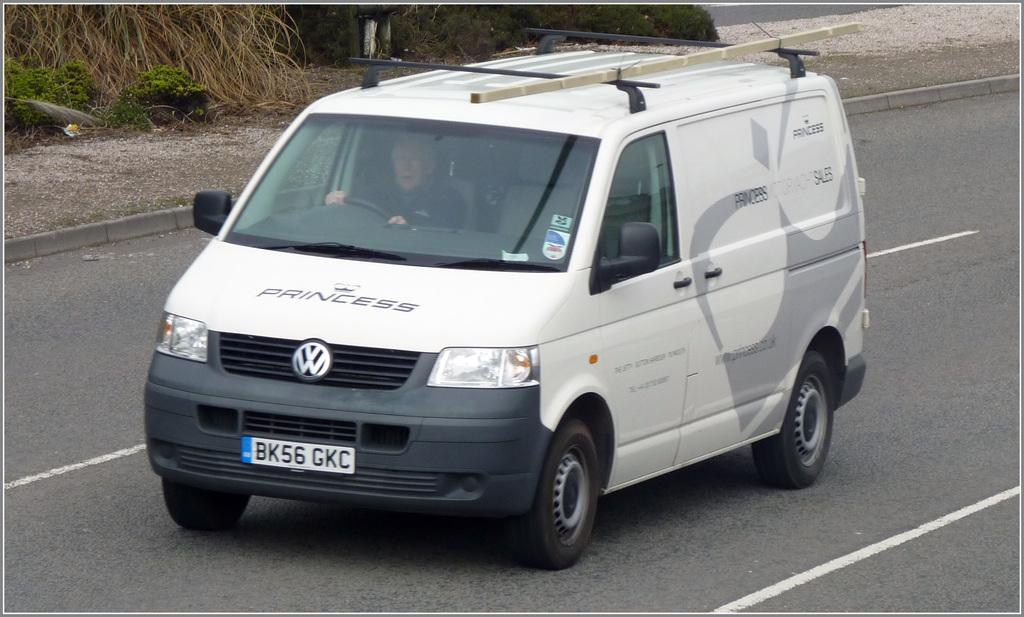<image>
Offer a succinct explanation of the picture presented. white van with a grey design and word princess on it in several places 